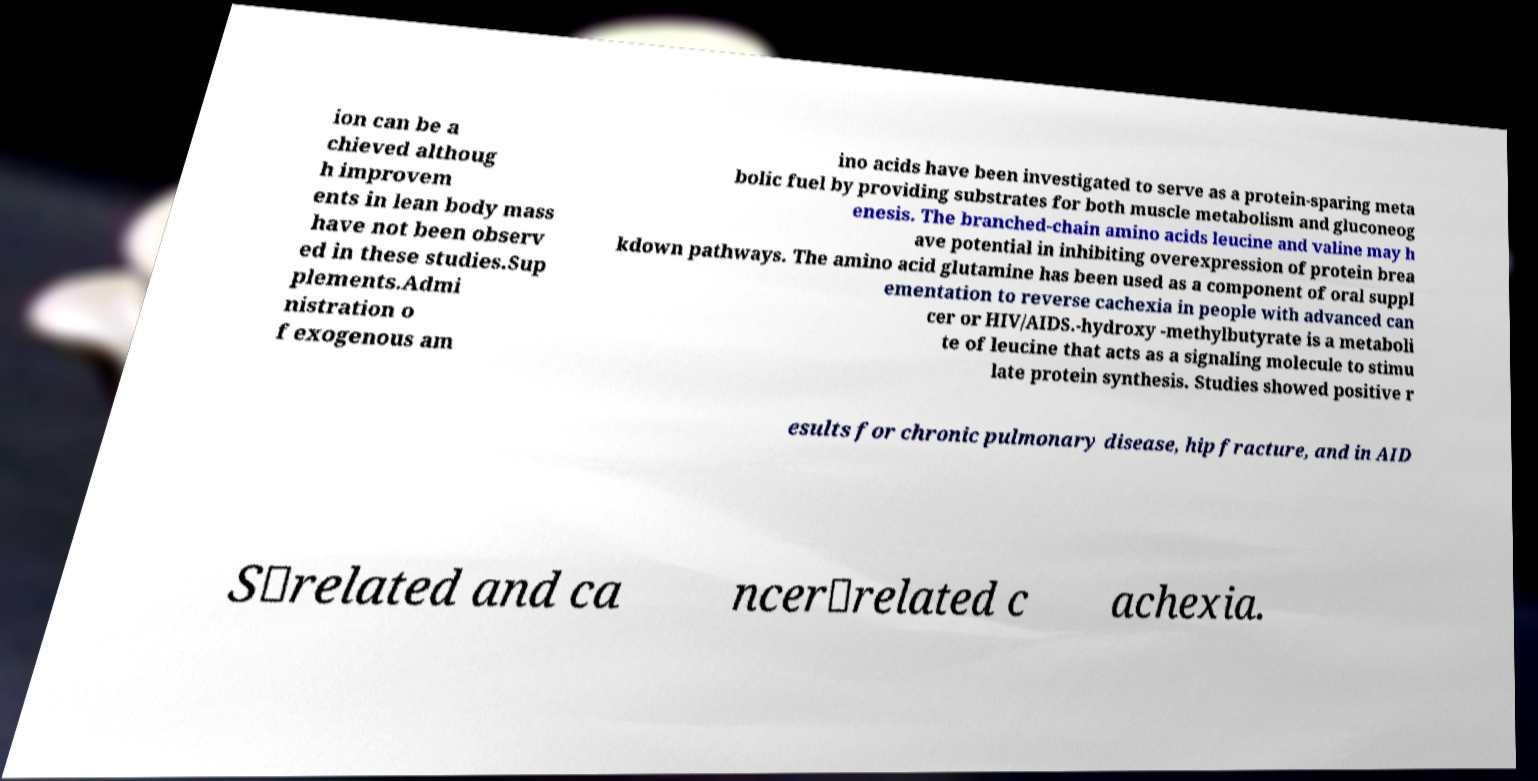I need the written content from this picture converted into text. Can you do that? ion can be a chieved althoug h improvem ents in lean body mass have not been observ ed in these studies.Sup plements.Admi nistration o f exogenous am ino acids have been investigated to serve as a protein-sparing meta bolic fuel by providing substrates for both muscle metabolism and gluconeog enesis. The branched-chain amino acids leucine and valine may h ave potential in inhibiting overexpression of protein brea kdown pathways. The amino acid glutamine has been used as a component of oral suppl ementation to reverse cachexia in people with advanced can cer or HIV/AIDS.-hydroxy -methylbutyrate is a metaboli te of leucine that acts as a signaling molecule to stimu late protein synthesis. Studies showed positive r esults for chronic pulmonary disease, hip fracture, and in AID S‐related and ca ncer‐related c achexia. 